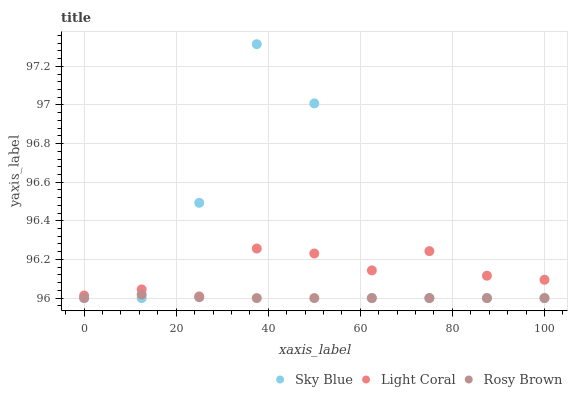Does Rosy Brown have the minimum area under the curve?
Answer yes or no. Yes. Does Sky Blue have the maximum area under the curve?
Answer yes or no. Yes. Does Sky Blue have the minimum area under the curve?
Answer yes or no. No. Does Rosy Brown have the maximum area under the curve?
Answer yes or no. No. Is Rosy Brown the smoothest?
Answer yes or no. Yes. Is Sky Blue the roughest?
Answer yes or no. Yes. Is Sky Blue the smoothest?
Answer yes or no. No. Is Rosy Brown the roughest?
Answer yes or no. No. Does Sky Blue have the lowest value?
Answer yes or no. Yes. Does Sky Blue have the highest value?
Answer yes or no. Yes. Does Rosy Brown have the highest value?
Answer yes or no. No. Is Rosy Brown less than Light Coral?
Answer yes or no. Yes. Is Light Coral greater than Rosy Brown?
Answer yes or no. Yes. Does Sky Blue intersect Rosy Brown?
Answer yes or no. Yes. Is Sky Blue less than Rosy Brown?
Answer yes or no. No. Is Sky Blue greater than Rosy Brown?
Answer yes or no. No. Does Rosy Brown intersect Light Coral?
Answer yes or no. No. 